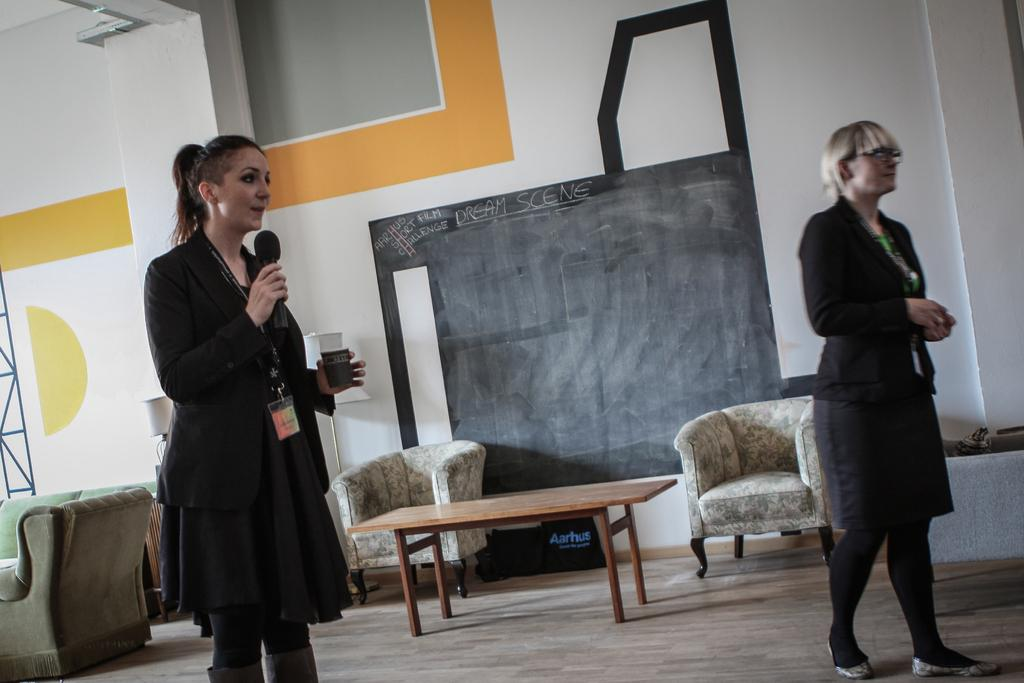How many women are present in the image? There are two women in the image. What is one of the women holding? One of the women is holding a mic. What type of furniture can be seen in the background of the image? There is a sofa set and a table visible in the background of the image. What is the primary feature of the background? The primary feature of the background is a wall. Can you see any friends or uncles in the image? There is no mention of friends or uncles in the image; it only features two women. Is there a tree visible in the image? There is no tree present in the image. 